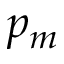<formula> <loc_0><loc_0><loc_500><loc_500>p _ { m }</formula> 